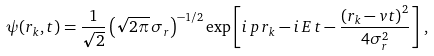<formula> <loc_0><loc_0><loc_500><loc_500>\psi ( r _ { k } , t ) = \frac { 1 } { \sqrt { 2 } } \left ( \sqrt { 2 \pi } \, \sigma _ { r } \right ) ^ { - 1 / 2 } \exp \left [ i \, p \, r _ { k } - i \, E \, t - \frac { \left ( r _ { k } - v t \right ) ^ { 2 } } { 4 \sigma _ { r } ^ { 2 } } \right ] \, ,</formula> 